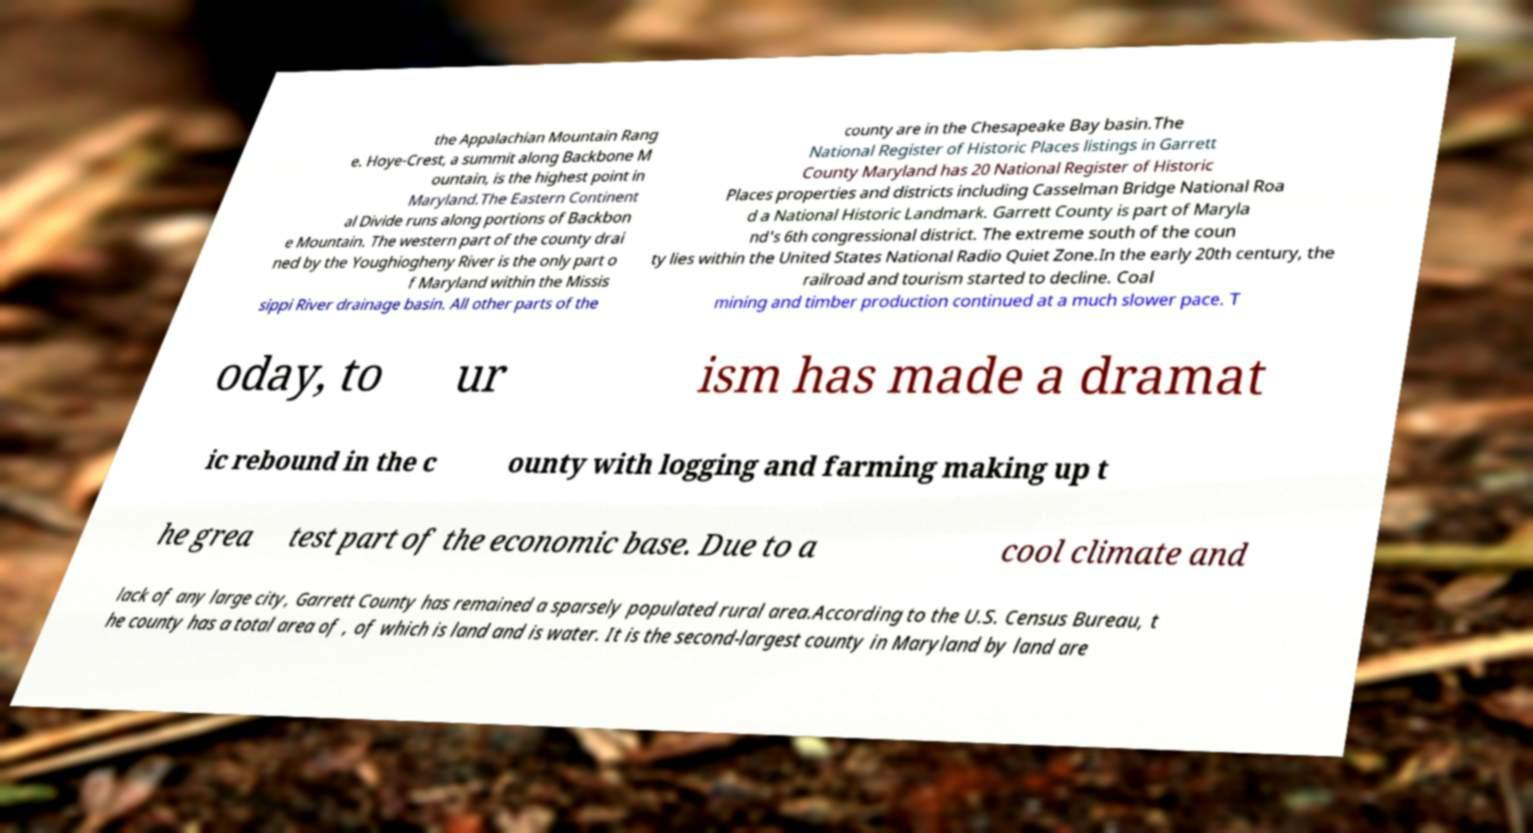For documentation purposes, I need the text within this image transcribed. Could you provide that? the Appalachian Mountain Rang e. Hoye-Crest, a summit along Backbone M ountain, is the highest point in Maryland.The Eastern Continent al Divide runs along portions of Backbon e Mountain. The western part of the county drai ned by the Youghiogheny River is the only part o f Maryland within the Missis sippi River drainage basin. All other parts of the county are in the Chesapeake Bay basin.The National Register of Historic Places listings in Garrett County Maryland has 20 National Register of Historic Places properties and districts including Casselman Bridge National Roa d a National Historic Landmark. Garrett County is part of Maryla nd's 6th congressional district. The extreme south of the coun ty lies within the United States National Radio Quiet Zone.In the early 20th century, the railroad and tourism started to decline. Coal mining and timber production continued at a much slower pace. T oday, to ur ism has made a dramat ic rebound in the c ounty with logging and farming making up t he grea test part of the economic base. Due to a cool climate and lack of any large city, Garrett County has remained a sparsely populated rural area.According to the U.S. Census Bureau, t he county has a total area of , of which is land and is water. It is the second-largest county in Maryland by land are 